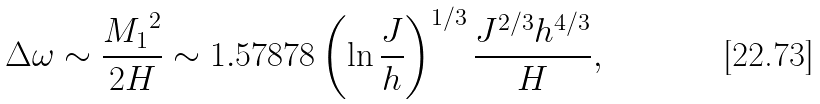<formula> <loc_0><loc_0><loc_500><loc_500>\Delta \omega \sim \frac { { M _ { 1 } } ^ { 2 } } { 2 H } \sim 1 . 5 7 8 7 8 \left ( \ln { \frac { J } { h } } \right ) ^ { 1 / 3 } \frac { J ^ { 2 / 3 } h ^ { 4 / 3 } } { H } ,</formula> 